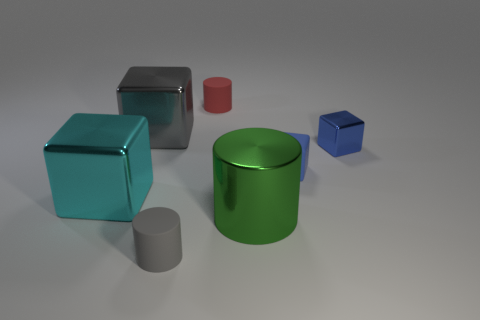Subtract 1 blocks. How many blocks are left? 3 Add 1 small cyan things. How many objects exist? 8 Subtract all cubes. How many objects are left? 3 Subtract 0 purple cylinders. How many objects are left? 7 Subtract all brown spheres. Subtract all cyan cubes. How many objects are left? 6 Add 4 tiny gray cylinders. How many tiny gray cylinders are left? 5 Add 1 rubber cylinders. How many rubber cylinders exist? 3 